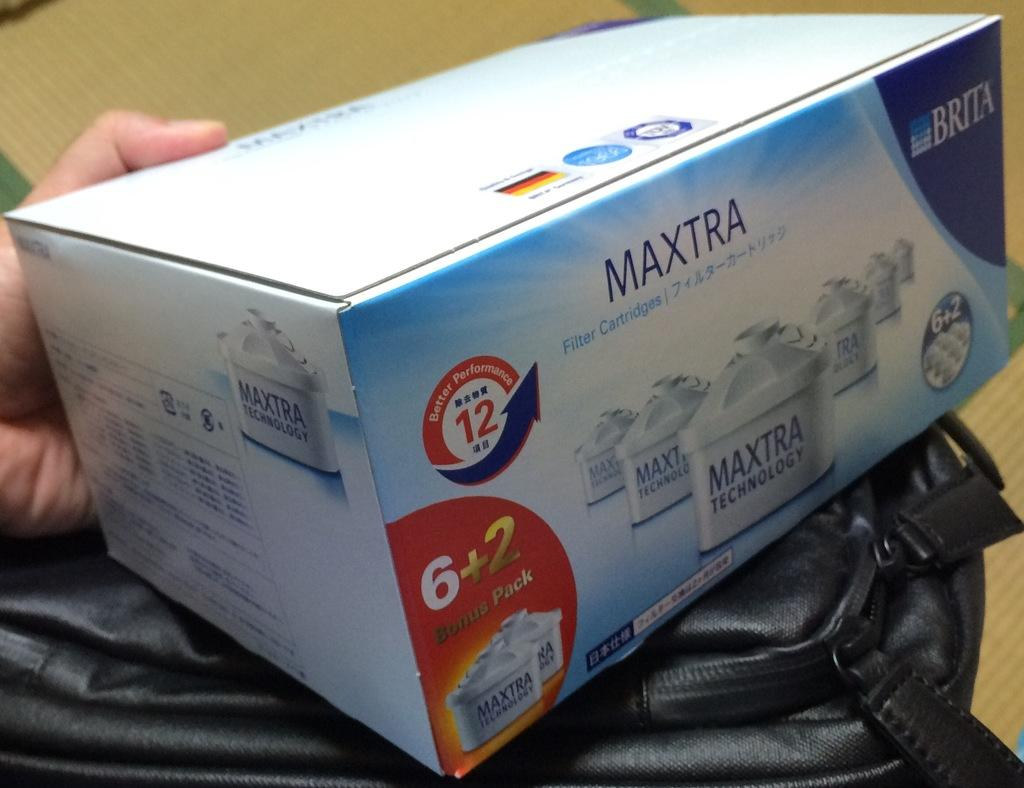<image>
Share a concise interpretation of the image provided. A blue box of 8 Maxtra Filter Cartridges. 